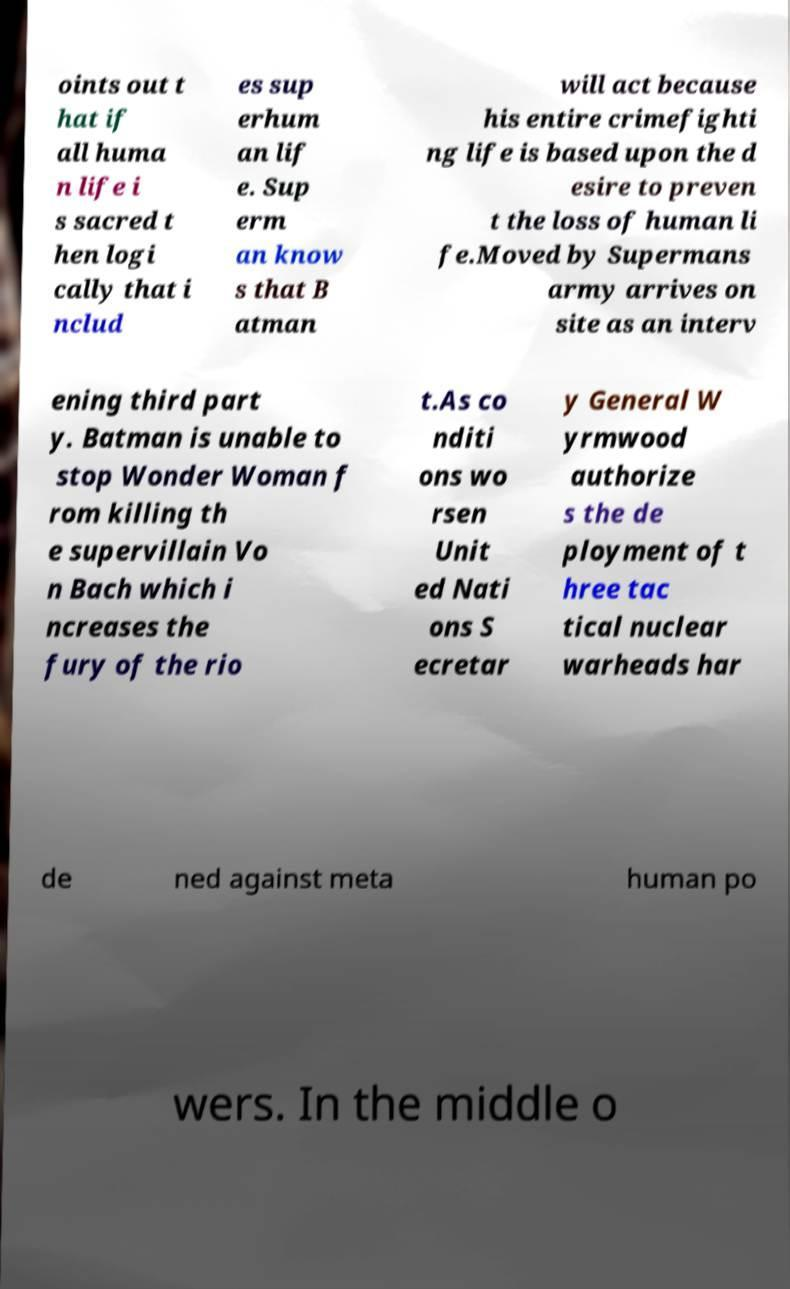I need the written content from this picture converted into text. Can you do that? oints out t hat if all huma n life i s sacred t hen logi cally that i nclud es sup erhum an lif e. Sup erm an know s that B atman will act because his entire crimefighti ng life is based upon the d esire to preven t the loss of human li fe.Moved by Supermans army arrives on site as an interv ening third part y. Batman is unable to stop Wonder Woman f rom killing th e supervillain Vo n Bach which i ncreases the fury of the rio t.As co nditi ons wo rsen Unit ed Nati ons S ecretar y General W yrmwood authorize s the de ployment of t hree tac tical nuclear warheads har de ned against meta human po wers. In the middle o 